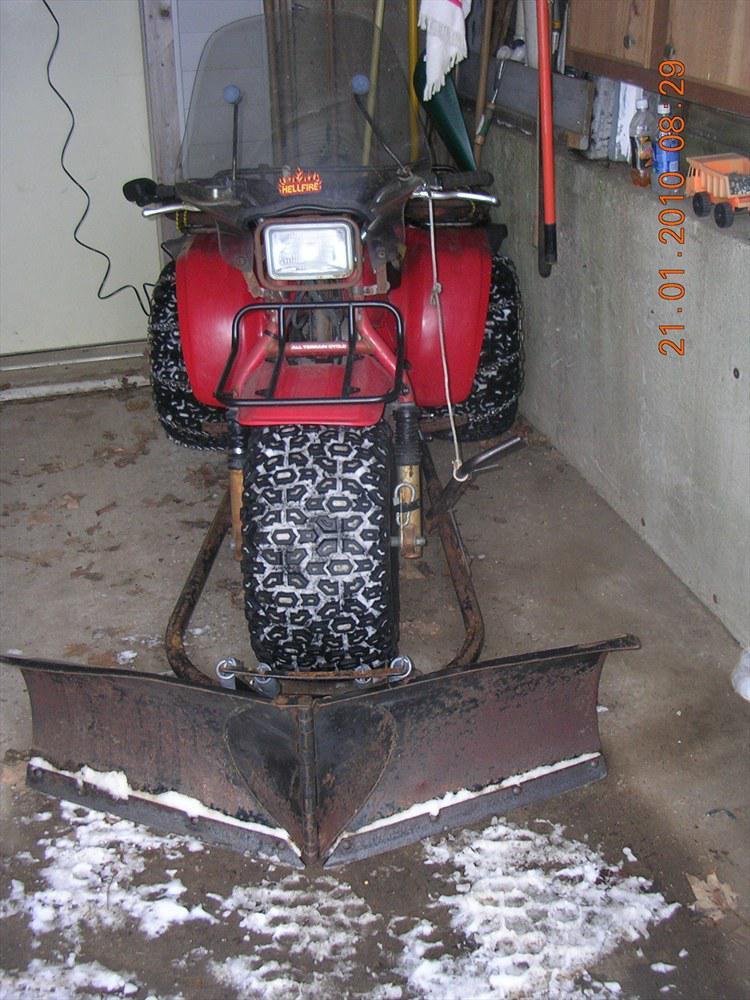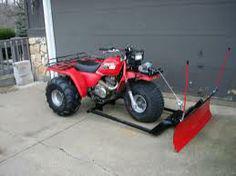The first image is the image on the left, the second image is the image on the right. Assess this claim about the two images: "There is a human in each image.". Correct or not? Answer yes or no. No. The first image is the image on the left, the second image is the image on the right. For the images shown, is this caption "Each red three wheeler snowplow is being operated by a rider." true? Answer yes or no. No. 